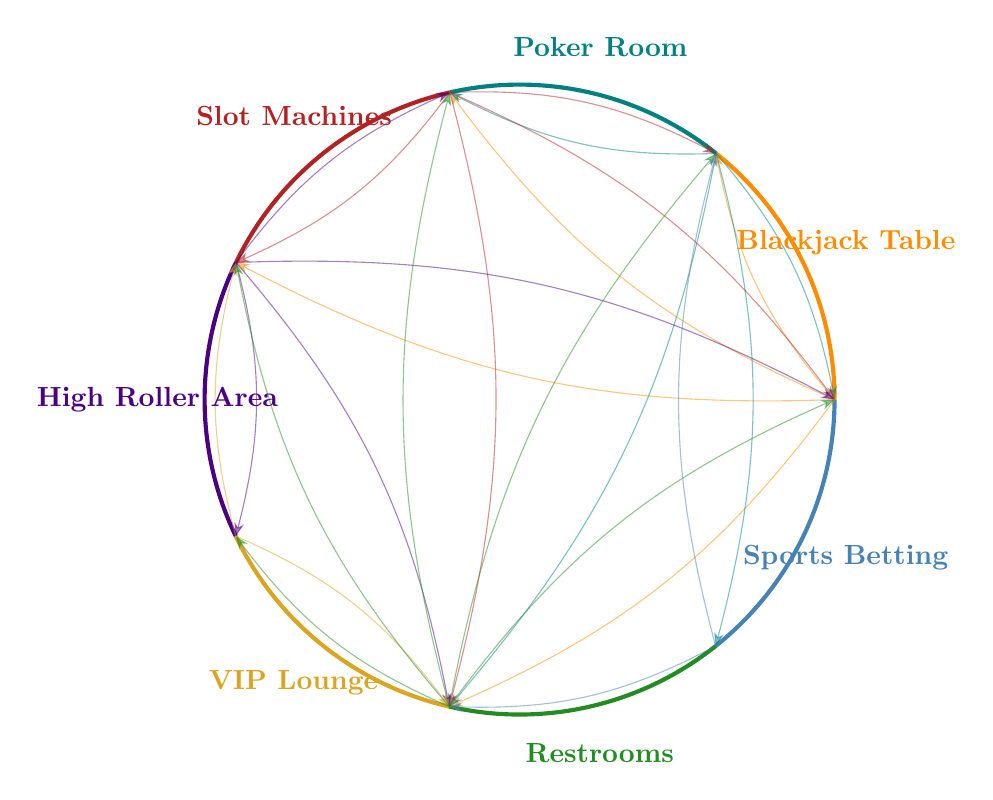What is the frequency of interactions between the Blackjack Table and the Restrooms? The diagram indicates that the frequency of interactions between the Blackjack Table and the Restrooms is 40. This information can be found by checking the interactions from the Blackjack Table node.
Answer: 40 Which location has the most frequent interactions with Slot Machines? Upon reviewing the diagram, the Slot Machines have the most frequent interactions with the Restrooms, with a frequency of 60. This is identified by looking at the arrows leading from the Slot Machines to other nodes.
Answer: Restrooms How many interactions does the High Roller Area have total? To find the total interactions for the High Roller Area, we sum the frequencies of its interactions: Blackjack Table (15) + Slot Machines (50) + VIP Lounge (10) + Restrooms (20) = 95. This includes all connections leading to and from the High Roller Area.
Answer: 95 Which area has the least number of interactions with the Restrooms? Reviewing the diagram shows that the VIP Lounge has only 10 interactions with the Restrooms, which is the least compared to all other areas. We find the connections from the Restrooms node and compare their frequencies.
Answer: VIP Lounge How does the frequency of interactions between the Poker Room and the Slot Machines compare to that of the Blackjack Table? The Poker Room interacts with the Slot Machines 35 times, while the Blackjack Table interacts with them 30 times. Comparing these two frequencies shows that the interaction between the Poker Room and the Slot Machines is higher than that of the Blackjack Table.
Answer: Higher What is the relationship between the Poker Room and Sports Betting Lounge in terms of interaction frequency? The interaction frequency between the Poker Room and the Sports Betting Lounge is 20. This is derived from examining the connections leading from the Poker Room node to the Sports Betting Lounge node specifically.
Answer: 20 Which table has the highest interaction frequency with the High Roller Area? The diagram shows that the highest interaction frequency with the High Roller Area comes from the Slot Machines, with a frequency of 50. This is determined by checking the connections from the High Roller Area to other nodes.
Answer: Slot Machines Is there any interaction between the Sports Betting Lounge and the Blackjack Table? There is no direct interaction indicated in the diagram between the Sports Betting Lounge and the Blackjack Table, as no arrow connects these two nodes directly. Instead, we can validate the presence or absence of interactions by inspecting the cords in the diagram.
Answer: No 